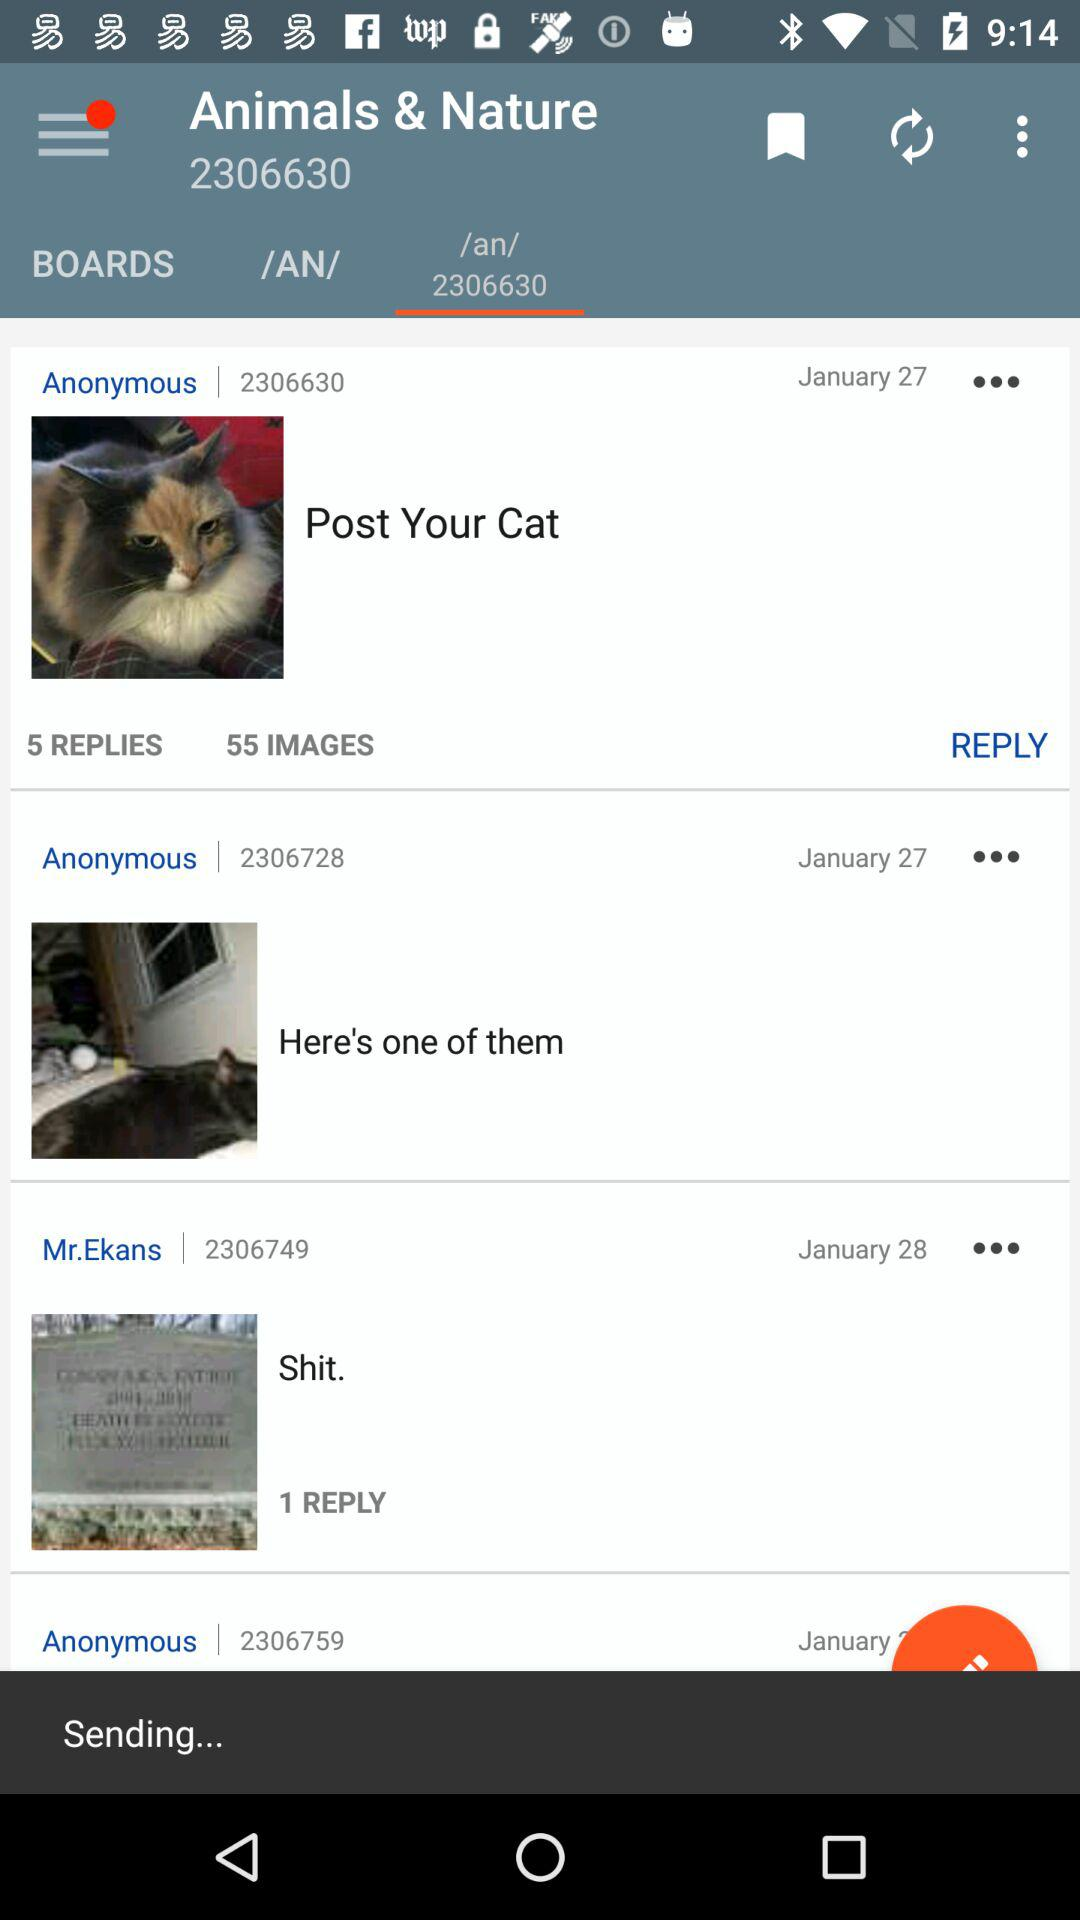How many images are there in "Post Your Cat"? There are 55 images in "Post Your Cat". 